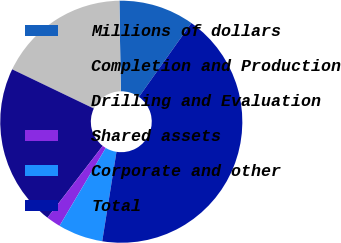<chart> <loc_0><loc_0><loc_500><loc_500><pie_chart><fcel>Millions of dollars<fcel>Completion and Production<fcel>Drilling and Evaluation<fcel>Shared assets<fcel>Corporate and other<fcel>Total<nl><fcel>10.08%<fcel>17.62%<fcel>21.69%<fcel>1.92%<fcel>6.0%<fcel>42.69%<nl></chart> 